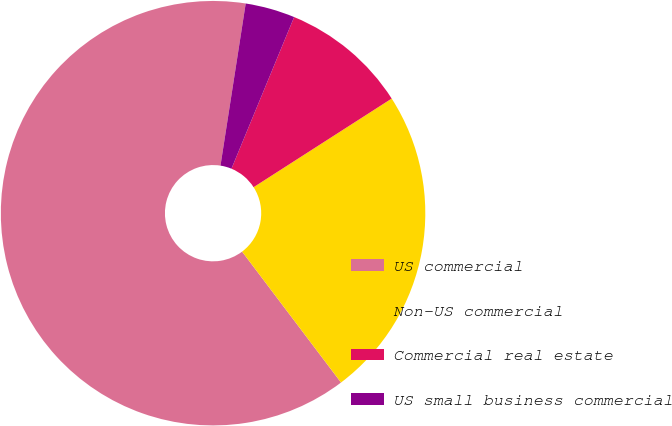Convert chart. <chart><loc_0><loc_0><loc_500><loc_500><pie_chart><fcel>US commercial<fcel>Non-US commercial<fcel>Commercial real estate<fcel>US small business commercial<nl><fcel>62.75%<fcel>23.78%<fcel>9.68%<fcel>3.78%<nl></chart> 